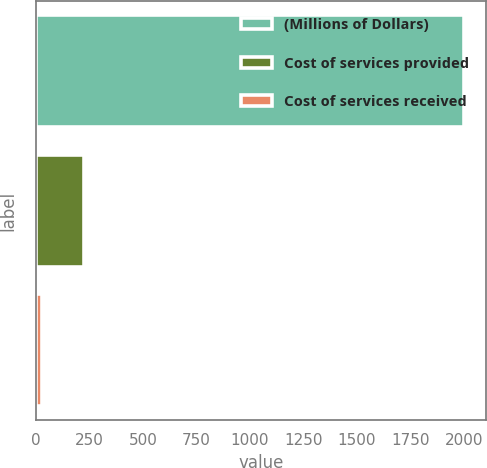Convert chart. <chart><loc_0><loc_0><loc_500><loc_500><bar_chart><fcel>(Millions of Dollars)<fcel>Cost of services provided<fcel>Cost of services received<nl><fcel>2003<fcel>222.8<fcel>25<nl></chart> 